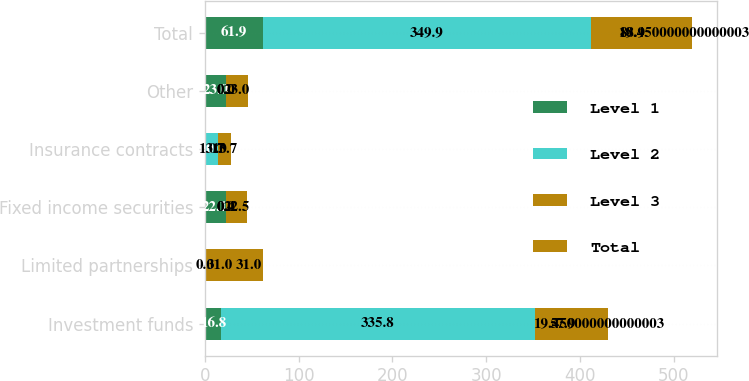Convert chart to OTSL. <chart><loc_0><loc_0><loc_500><loc_500><stacked_bar_chart><ecel><fcel>Investment funds<fcel>Limited partnerships<fcel>Fixed income securities<fcel>Insurance contracts<fcel>Other<fcel>Total<nl><fcel>Level 1<fcel>16.8<fcel>0<fcel>22.1<fcel>0<fcel>23<fcel>61.9<nl><fcel>Level 2<fcel>335.8<fcel>0<fcel>0.4<fcel>13.7<fcel>0<fcel>349.9<nl><fcel>Level 3<fcel>57.9<fcel>31<fcel>0<fcel>0<fcel>0<fcel>88.9<nl><fcel>Total<fcel>19.45<fcel>31<fcel>22.5<fcel>13.7<fcel>23<fcel>19.45<nl></chart> 